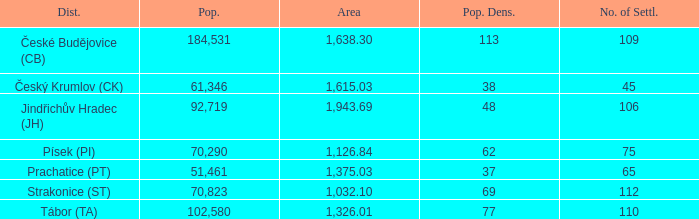What is the population density of the area with a population larger than 92,719? 2.0. Could you parse the entire table? {'header': ['Dist.', 'Pop.', 'Area', 'Pop. Dens.', 'No. of Settl.'], 'rows': [['České Budějovice (CB)', '184,531', '1,638.30', '113', '109'], ['Český Krumlov (CK)', '61,346', '1,615.03', '38', '45'], ['Jindřichův Hradec (JH)', '92,719', '1,943.69', '48', '106'], ['Písek (PI)', '70,290', '1,126.84', '62', '75'], ['Prachatice (PT)', '51,461', '1,375.03', '37', '65'], ['Strakonice (ST)', '70,823', '1,032.10', '69', '112'], ['Tábor (TA)', '102,580', '1,326.01', '77', '110']]} 